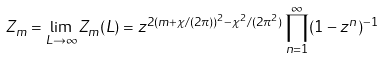<formula> <loc_0><loc_0><loc_500><loc_500>Z _ { m } = \lim _ { L \to \infty } Z _ { m } ( L ) = z ^ { 2 ( m + \chi / ( 2 \pi ) ) ^ { 2 } - \chi ^ { 2 } / ( 2 \pi ^ { 2 } ) } \prod _ { n = 1 } ^ { \infty } ( 1 - z ^ { n } ) ^ { - 1 }</formula> 